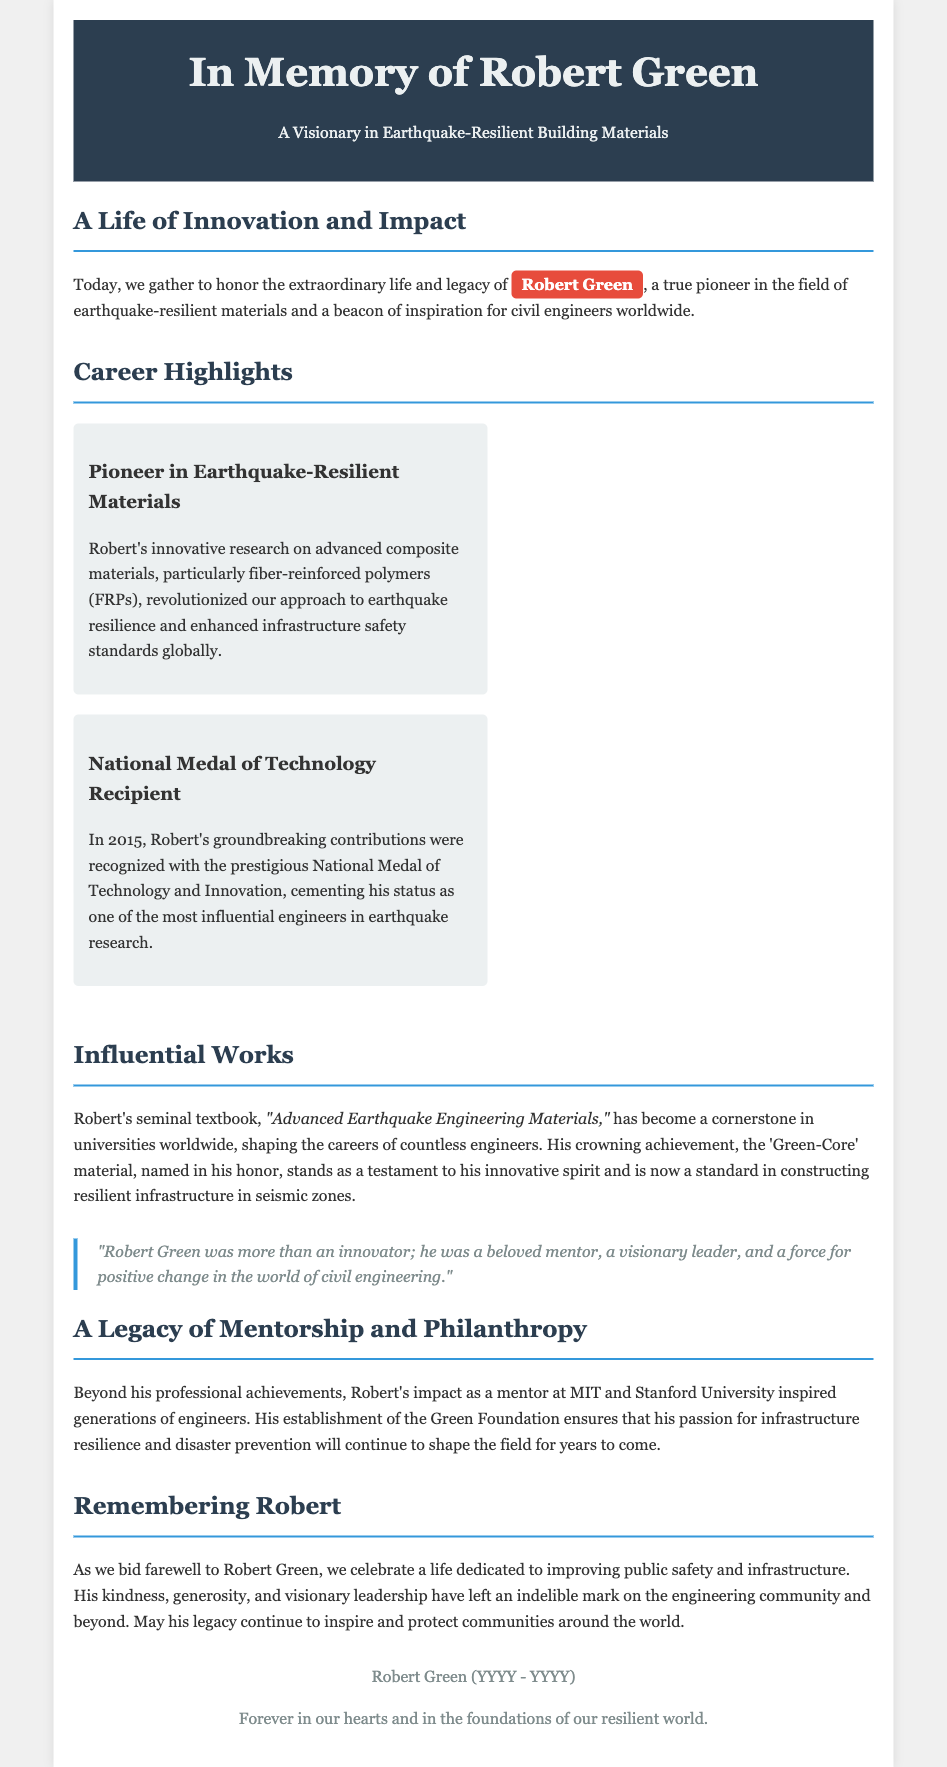What is Robert Green known for? Robert Green is known as a pioneer in earthquake-resilient materials, particularly for his innovative research on advanced composite materials.
Answer: Pioneer in earthquake-resilient materials What prestigious award did Robert receive in 2015? Robert received the National Medal of Technology and Innovation in 2015 for his groundbreaking contributions.
Answer: National Medal of Technology What is the title of Robert's seminal textbook? The title of Robert's seminal textbook is "Advanced Earthquake Engineering Materials."
Answer: Advanced Earthquake Engineering Materials What is the name of the material named in Robert's honor? The material named in Robert's honor is called 'Green-Core.'
Answer: Green-Core What institution did Robert mentor at? Robert mentored at MIT and Stanford University.
Answer: MIT and Stanford University What does the Green Foundation represent? The Green Foundation represents Robert's passion for infrastructure resilience and disaster prevention.
Answer: Infrastructure resilience How did Robert impact the engineering community? Robert's impact included his role as a mentor, leader, and philanthropic figure, shaping future engineers and promoting safety standards.
Answer: Mentor and leader What is the main theme of Robert's legacy? The main theme of Robert's legacy is improving public safety and infrastructure through innovative engineering solutions.
Answer: Public safety and infrastructure 